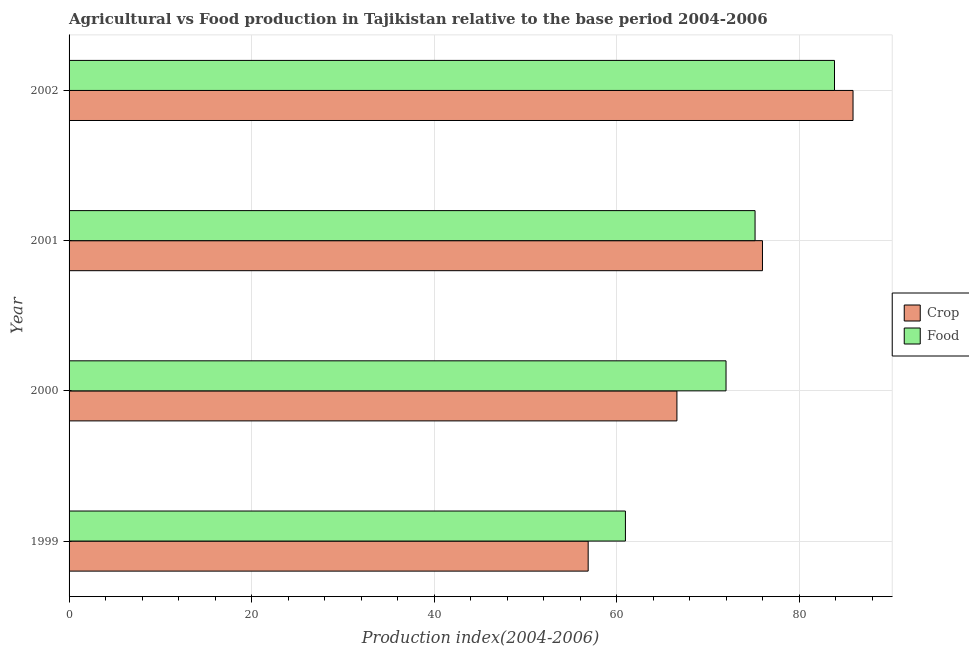How many different coloured bars are there?
Your answer should be very brief. 2. How many groups of bars are there?
Offer a very short reply. 4. Are the number of bars on each tick of the Y-axis equal?
Provide a short and direct response. Yes. How many bars are there on the 4th tick from the bottom?
Keep it short and to the point. 2. What is the food production index in 2001?
Keep it short and to the point. 75.14. Across all years, what is the maximum food production index?
Your answer should be very brief. 83.84. Across all years, what is the minimum food production index?
Give a very brief answer. 60.94. In which year was the crop production index maximum?
Make the answer very short. 2002. What is the total food production index in the graph?
Offer a very short reply. 291.88. What is the difference between the food production index in 2001 and that in 2002?
Give a very brief answer. -8.7. What is the difference between the food production index in 2000 and the crop production index in 2001?
Give a very brief answer. -3.99. What is the average food production index per year?
Provide a succinct answer. 72.97. In the year 2000, what is the difference between the crop production index and food production index?
Your answer should be very brief. -5.38. In how many years, is the food production index greater than 40 ?
Provide a succinct answer. 4. What is the ratio of the food production index in 2000 to that in 2001?
Provide a succinct answer. 0.96. Is the food production index in 1999 less than that in 2001?
Keep it short and to the point. Yes. What is the difference between the highest and the lowest crop production index?
Your response must be concise. 29.01. Is the sum of the crop production index in 2001 and 2002 greater than the maximum food production index across all years?
Your answer should be very brief. Yes. What does the 2nd bar from the top in 2002 represents?
Give a very brief answer. Crop. What does the 1st bar from the bottom in 1999 represents?
Your response must be concise. Crop. Are all the bars in the graph horizontal?
Give a very brief answer. Yes. How many years are there in the graph?
Provide a short and direct response. 4. What is the difference between two consecutive major ticks on the X-axis?
Offer a terse response. 20. Are the values on the major ticks of X-axis written in scientific E-notation?
Provide a short and direct response. No. Does the graph contain any zero values?
Ensure brevity in your answer.  No. Does the graph contain grids?
Offer a terse response. Yes. How are the legend labels stacked?
Ensure brevity in your answer.  Vertical. What is the title of the graph?
Make the answer very short. Agricultural vs Food production in Tajikistan relative to the base period 2004-2006. Does "All education staff compensation" appear as one of the legend labels in the graph?
Your answer should be compact. No. What is the label or title of the X-axis?
Ensure brevity in your answer.  Production index(2004-2006). What is the label or title of the Y-axis?
Make the answer very short. Year. What is the Production index(2004-2006) of Crop in 1999?
Provide a short and direct response. 56.86. What is the Production index(2004-2006) of Food in 1999?
Provide a succinct answer. 60.94. What is the Production index(2004-2006) in Crop in 2000?
Offer a very short reply. 66.58. What is the Production index(2004-2006) in Food in 2000?
Provide a succinct answer. 71.96. What is the Production index(2004-2006) in Crop in 2001?
Provide a short and direct response. 75.95. What is the Production index(2004-2006) of Food in 2001?
Offer a terse response. 75.14. What is the Production index(2004-2006) of Crop in 2002?
Your response must be concise. 85.87. What is the Production index(2004-2006) in Food in 2002?
Ensure brevity in your answer.  83.84. Across all years, what is the maximum Production index(2004-2006) of Crop?
Give a very brief answer. 85.87. Across all years, what is the maximum Production index(2004-2006) in Food?
Provide a succinct answer. 83.84. Across all years, what is the minimum Production index(2004-2006) of Crop?
Provide a short and direct response. 56.86. Across all years, what is the minimum Production index(2004-2006) of Food?
Offer a very short reply. 60.94. What is the total Production index(2004-2006) of Crop in the graph?
Provide a succinct answer. 285.26. What is the total Production index(2004-2006) of Food in the graph?
Your response must be concise. 291.88. What is the difference between the Production index(2004-2006) of Crop in 1999 and that in 2000?
Your answer should be compact. -9.72. What is the difference between the Production index(2004-2006) of Food in 1999 and that in 2000?
Your answer should be compact. -11.02. What is the difference between the Production index(2004-2006) in Crop in 1999 and that in 2001?
Provide a short and direct response. -19.09. What is the difference between the Production index(2004-2006) of Crop in 1999 and that in 2002?
Give a very brief answer. -29.01. What is the difference between the Production index(2004-2006) in Food in 1999 and that in 2002?
Keep it short and to the point. -22.9. What is the difference between the Production index(2004-2006) in Crop in 2000 and that in 2001?
Provide a short and direct response. -9.37. What is the difference between the Production index(2004-2006) in Food in 2000 and that in 2001?
Give a very brief answer. -3.18. What is the difference between the Production index(2004-2006) in Crop in 2000 and that in 2002?
Your response must be concise. -19.29. What is the difference between the Production index(2004-2006) of Food in 2000 and that in 2002?
Ensure brevity in your answer.  -11.88. What is the difference between the Production index(2004-2006) in Crop in 2001 and that in 2002?
Provide a short and direct response. -9.92. What is the difference between the Production index(2004-2006) in Food in 2001 and that in 2002?
Your response must be concise. -8.7. What is the difference between the Production index(2004-2006) in Crop in 1999 and the Production index(2004-2006) in Food in 2000?
Provide a succinct answer. -15.1. What is the difference between the Production index(2004-2006) in Crop in 1999 and the Production index(2004-2006) in Food in 2001?
Offer a terse response. -18.28. What is the difference between the Production index(2004-2006) in Crop in 1999 and the Production index(2004-2006) in Food in 2002?
Your response must be concise. -26.98. What is the difference between the Production index(2004-2006) in Crop in 2000 and the Production index(2004-2006) in Food in 2001?
Provide a succinct answer. -8.56. What is the difference between the Production index(2004-2006) in Crop in 2000 and the Production index(2004-2006) in Food in 2002?
Offer a very short reply. -17.26. What is the difference between the Production index(2004-2006) in Crop in 2001 and the Production index(2004-2006) in Food in 2002?
Ensure brevity in your answer.  -7.89. What is the average Production index(2004-2006) in Crop per year?
Give a very brief answer. 71.31. What is the average Production index(2004-2006) in Food per year?
Your answer should be very brief. 72.97. In the year 1999, what is the difference between the Production index(2004-2006) of Crop and Production index(2004-2006) of Food?
Provide a short and direct response. -4.08. In the year 2000, what is the difference between the Production index(2004-2006) of Crop and Production index(2004-2006) of Food?
Make the answer very short. -5.38. In the year 2001, what is the difference between the Production index(2004-2006) in Crop and Production index(2004-2006) in Food?
Give a very brief answer. 0.81. In the year 2002, what is the difference between the Production index(2004-2006) in Crop and Production index(2004-2006) in Food?
Provide a succinct answer. 2.03. What is the ratio of the Production index(2004-2006) of Crop in 1999 to that in 2000?
Offer a terse response. 0.85. What is the ratio of the Production index(2004-2006) of Food in 1999 to that in 2000?
Ensure brevity in your answer.  0.85. What is the ratio of the Production index(2004-2006) in Crop in 1999 to that in 2001?
Provide a short and direct response. 0.75. What is the ratio of the Production index(2004-2006) in Food in 1999 to that in 2001?
Your answer should be very brief. 0.81. What is the ratio of the Production index(2004-2006) of Crop in 1999 to that in 2002?
Provide a succinct answer. 0.66. What is the ratio of the Production index(2004-2006) in Food in 1999 to that in 2002?
Ensure brevity in your answer.  0.73. What is the ratio of the Production index(2004-2006) of Crop in 2000 to that in 2001?
Make the answer very short. 0.88. What is the ratio of the Production index(2004-2006) in Food in 2000 to that in 2001?
Offer a terse response. 0.96. What is the ratio of the Production index(2004-2006) of Crop in 2000 to that in 2002?
Provide a short and direct response. 0.78. What is the ratio of the Production index(2004-2006) of Food in 2000 to that in 2002?
Your answer should be very brief. 0.86. What is the ratio of the Production index(2004-2006) of Crop in 2001 to that in 2002?
Offer a very short reply. 0.88. What is the ratio of the Production index(2004-2006) of Food in 2001 to that in 2002?
Give a very brief answer. 0.9. What is the difference between the highest and the second highest Production index(2004-2006) of Crop?
Your answer should be very brief. 9.92. What is the difference between the highest and the second highest Production index(2004-2006) in Food?
Make the answer very short. 8.7. What is the difference between the highest and the lowest Production index(2004-2006) of Crop?
Ensure brevity in your answer.  29.01. What is the difference between the highest and the lowest Production index(2004-2006) in Food?
Ensure brevity in your answer.  22.9. 